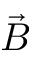Convert formula to latex. <formula><loc_0><loc_0><loc_500><loc_500>\vec { B }</formula> 